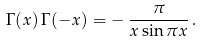<formula> <loc_0><loc_0><loc_500><loc_500>\Gamma ( x ) \, \Gamma ( - x ) = - \, \frac { \pi } { x \sin \pi x } \, .</formula> 